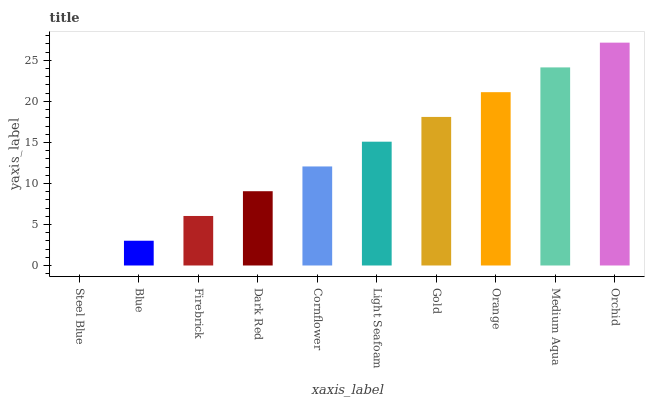Is Steel Blue the minimum?
Answer yes or no. Yes. Is Orchid the maximum?
Answer yes or no. Yes. Is Blue the minimum?
Answer yes or no. No. Is Blue the maximum?
Answer yes or no. No. Is Blue greater than Steel Blue?
Answer yes or no. Yes. Is Steel Blue less than Blue?
Answer yes or no. Yes. Is Steel Blue greater than Blue?
Answer yes or no. No. Is Blue less than Steel Blue?
Answer yes or no. No. Is Light Seafoam the high median?
Answer yes or no. Yes. Is Cornflower the low median?
Answer yes or no. Yes. Is Firebrick the high median?
Answer yes or no. No. Is Orchid the low median?
Answer yes or no. No. 